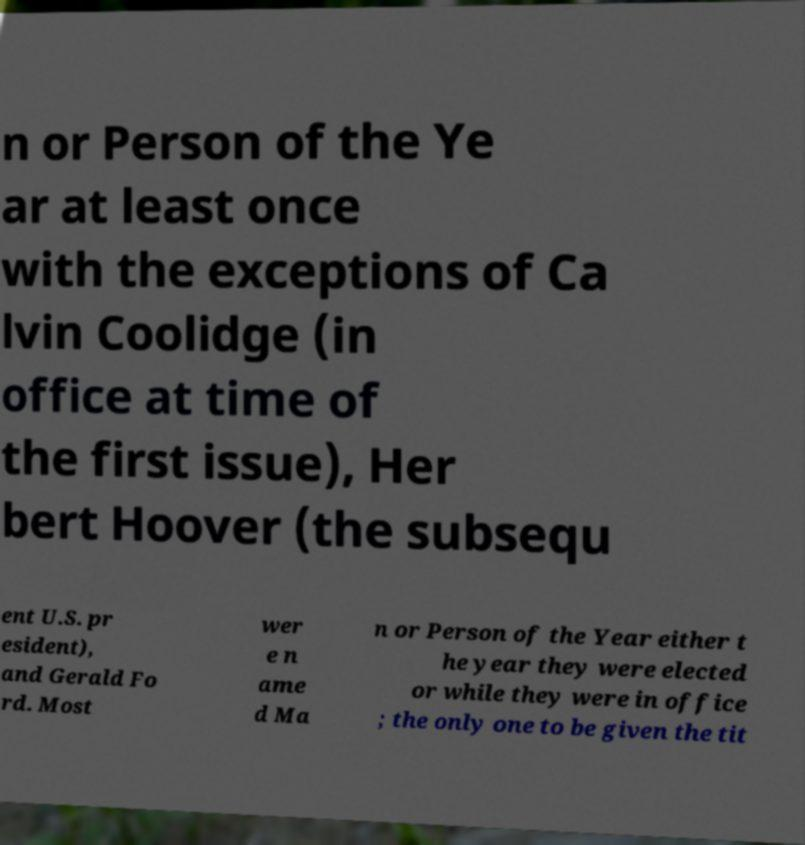Can you accurately transcribe the text from the provided image for me? n or Person of the Ye ar at least once with the exceptions of Ca lvin Coolidge (in office at time of the first issue), Her bert Hoover (the subsequ ent U.S. pr esident), and Gerald Fo rd. Most wer e n ame d Ma n or Person of the Year either t he year they were elected or while they were in office ; the only one to be given the tit 